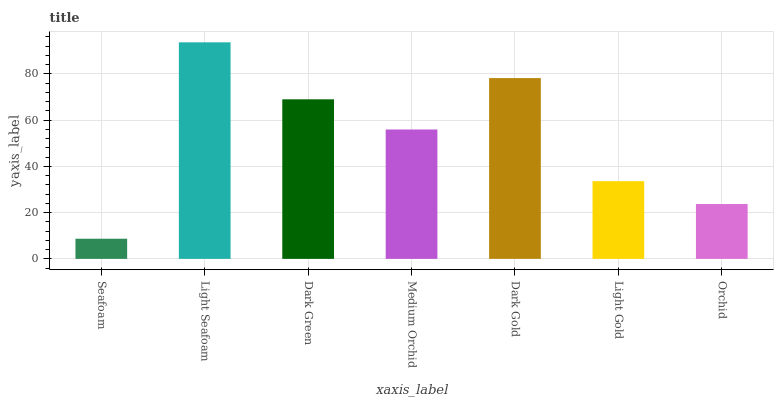Is Seafoam the minimum?
Answer yes or no. Yes. Is Light Seafoam the maximum?
Answer yes or no. Yes. Is Dark Green the minimum?
Answer yes or no. No. Is Dark Green the maximum?
Answer yes or no. No. Is Light Seafoam greater than Dark Green?
Answer yes or no. Yes. Is Dark Green less than Light Seafoam?
Answer yes or no. Yes. Is Dark Green greater than Light Seafoam?
Answer yes or no. No. Is Light Seafoam less than Dark Green?
Answer yes or no. No. Is Medium Orchid the high median?
Answer yes or no. Yes. Is Medium Orchid the low median?
Answer yes or no. Yes. Is Light Gold the high median?
Answer yes or no. No. Is Seafoam the low median?
Answer yes or no. No. 